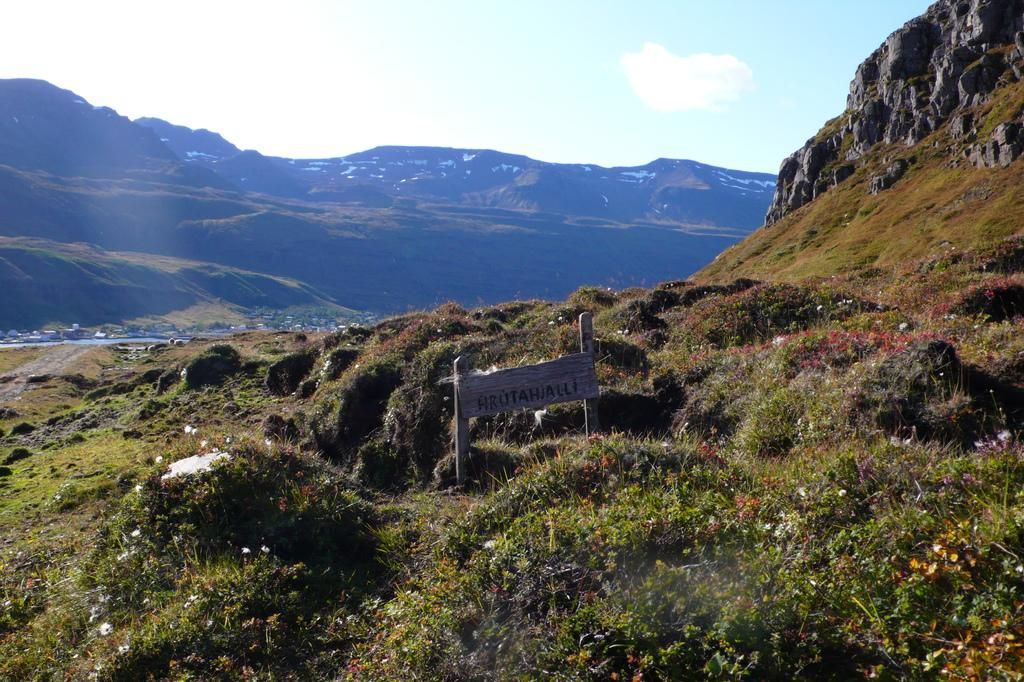What is the main object in the image? There is a name board in the image. What type of plants can be seen in the image? There are plants with flowers in the image. What geographical features are present in the image? There are hills in the image. What other natural elements can be seen in the image? There are trees in the image. What can be seen in the background of the image? The sky is visible in the background of the image. What type of cake is being served on the name board in the image? There is no cake present in the image; it features a name board, plants, hills, trees, and the sky. 